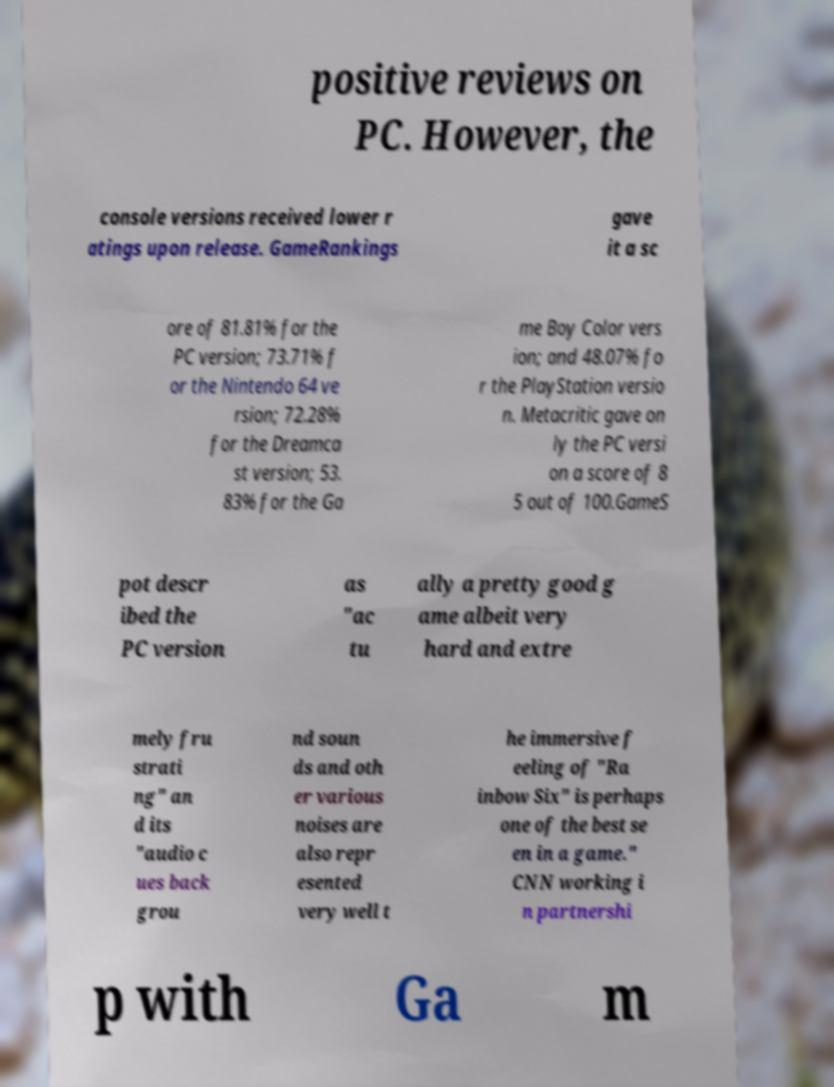Could you extract and type out the text from this image? positive reviews on PC. However, the console versions received lower r atings upon release. GameRankings gave it a sc ore of 81.81% for the PC version; 73.71% f or the Nintendo 64 ve rsion; 72.28% for the Dreamca st version; 53. 83% for the Ga me Boy Color vers ion; and 48.07% fo r the PlayStation versio n. Metacritic gave on ly the PC versi on a score of 8 5 out of 100.GameS pot descr ibed the PC version as "ac tu ally a pretty good g ame albeit very hard and extre mely fru strati ng" an d its "audio c ues back grou nd soun ds and oth er various noises are also repr esented very well t he immersive f eeling of "Ra inbow Six" is perhaps one of the best se en in a game." CNN working i n partnershi p with Ga m 